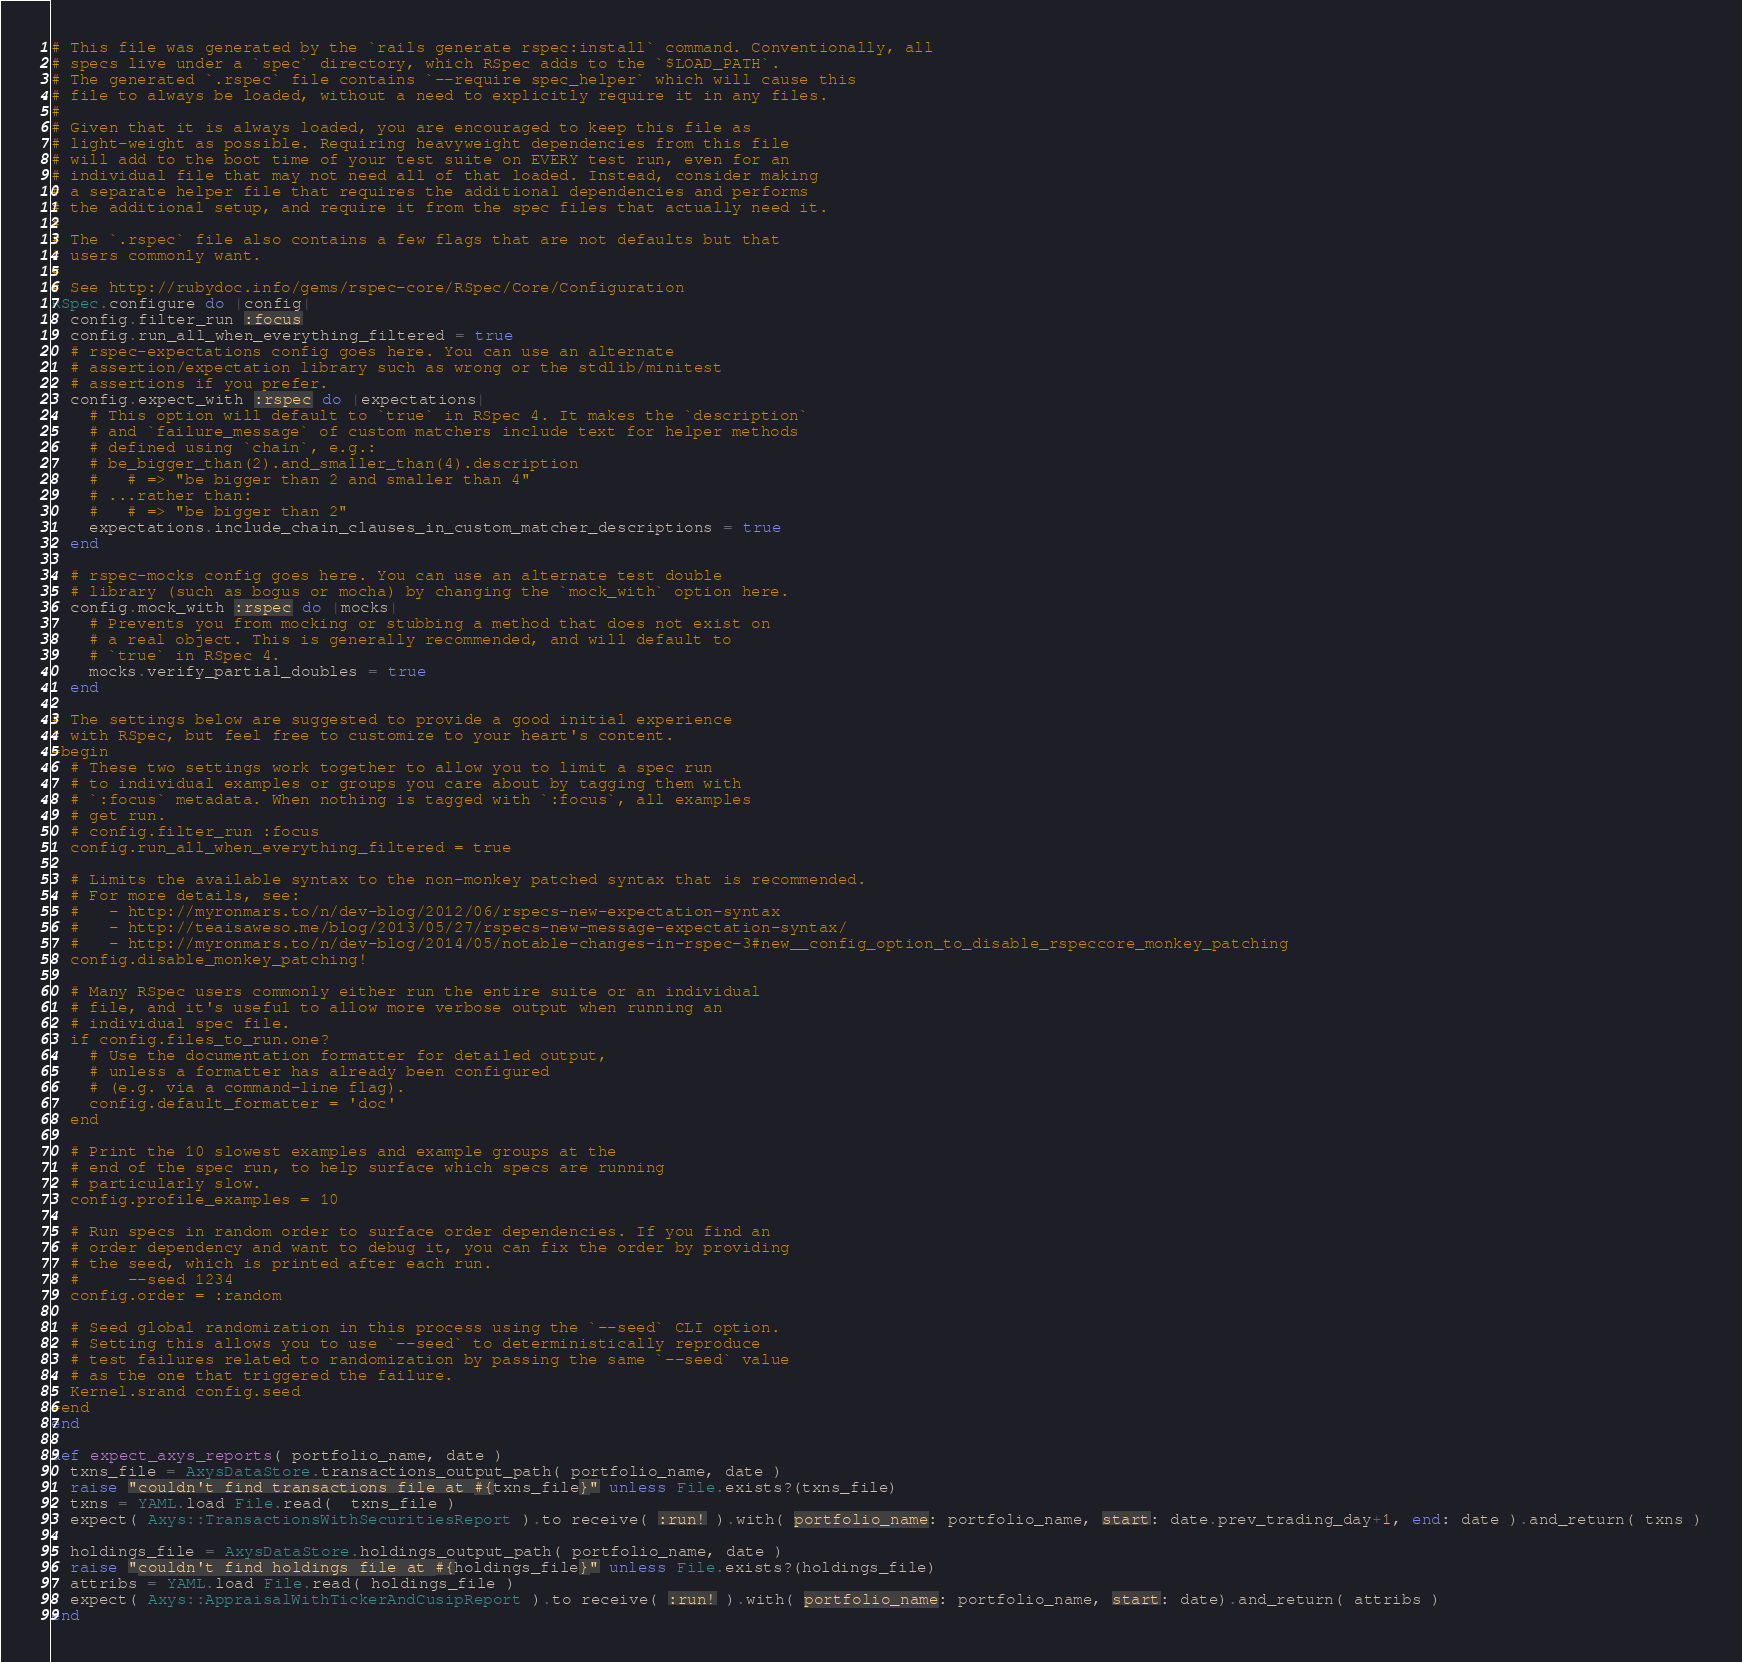<code> <loc_0><loc_0><loc_500><loc_500><_Ruby_># This file was generated by the `rails generate rspec:install` command. Conventionally, all
# specs live under a `spec` directory, which RSpec adds to the `$LOAD_PATH`.
# The generated `.rspec` file contains `--require spec_helper` which will cause this
# file to always be loaded, without a need to explicitly require it in any files.
#
# Given that it is always loaded, you are encouraged to keep this file as
# light-weight as possible. Requiring heavyweight dependencies from this file
# will add to the boot time of your test suite on EVERY test run, even for an
# individual file that may not need all of that loaded. Instead, consider making
# a separate helper file that requires the additional dependencies and performs
# the additional setup, and require it from the spec files that actually need it.
#
# The `.rspec` file also contains a few flags that are not defaults but that
# users commonly want.
#
# See http://rubydoc.info/gems/rspec-core/RSpec/Core/Configuration
RSpec.configure do |config|
  config.filter_run :focus
  config.run_all_when_everything_filtered = true
  # rspec-expectations config goes here. You can use an alternate
  # assertion/expectation library such as wrong or the stdlib/minitest
  # assertions if you prefer.
  config.expect_with :rspec do |expectations|
    # This option will default to `true` in RSpec 4. It makes the `description`
    # and `failure_message` of custom matchers include text for helper methods
    # defined using `chain`, e.g.:
    # be_bigger_than(2).and_smaller_than(4).description
    #   # => "be bigger than 2 and smaller than 4"
    # ...rather than:
    #   # => "be bigger than 2"
    expectations.include_chain_clauses_in_custom_matcher_descriptions = true
  end

  # rspec-mocks config goes here. You can use an alternate test double
  # library (such as bogus or mocha) by changing the `mock_with` option here.
  config.mock_with :rspec do |mocks|
    # Prevents you from mocking or stubbing a method that does not exist on
    # a real object. This is generally recommended, and will default to
    # `true` in RSpec 4.
    mocks.verify_partial_doubles = true
  end

# The settings below are suggested to provide a good initial experience
# with RSpec, but feel free to customize to your heart's content.
=begin
  # These two settings work together to allow you to limit a spec run
  # to individual examples or groups you care about by tagging them with
  # `:focus` metadata. When nothing is tagged with `:focus`, all examples
  # get run.
  # config.filter_run :focus
  config.run_all_when_everything_filtered = true

  # Limits the available syntax to the non-monkey patched syntax that is recommended.
  # For more details, see:
  #   - http://myronmars.to/n/dev-blog/2012/06/rspecs-new-expectation-syntax
  #   - http://teaisaweso.me/blog/2013/05/27/rspecs-new-message-expectation-syntax/
  #   - http://myronmars.to/n/dev-blog/2014/05/notable-changes-in-rspec-3#new__config_option_to_disable_rspeccore_monkey_patching
  config.disable_monkey_patching!

  # Many RSpec users commonly either run the entire suite or an individual
  # file, and it's useful to allow more verbose output when running an
  # individual spec file.
  if config.files_to_run.one?
    # Use the documentation formatter for detailed output,
    # unless a formatter has already been configured
    # (e.g. via a command-line flag).
    config.default_formatter = 'doc'
  end

  # Print the 10 slowest examples and example groups at the
  # end of the spec run, to help surface which specs are running
  # particularly slow.
  config.profile_examples = 10

  # Run specs in random order to surface order dependencies. If you find an
  # order dependency and want to debug it, you can fix the order by providing
  # the seed, which is printed after each run.
  #     --seed 1234
  config.order = :random

  # Seed global randomization in this process using the `--seed` CLI option.
  # Setting this allows you to use `--seed` to deterministically reproduce
  # test failures related to randomization by passing the same `--seed` value
  # as the one that triggered the failure.
  Kernel.srand config.seed
=end
end

def expect_axys_reports( portfolio_name, date )
  txns_file = AxysDataStore.transactions_output_path( portfolio_name, date )
  raise "couldn't find transactions file at #{txns_file}" unless File.exists?(txns_file)
  txns = YAML.load File.read(  txns_file )
  expect( Axys::TransactionsWithSecuritiesReport ).to receive( :run! ).with( portfolio_name: portfolio_name, start: date.prev_trading_day+1, end: date ).and_return( txns )

  holdings_file = AxysDataStore.holdings_output_path( portfolio_name, date )
  raise "couldn't find holdings file at #{holdings_file}" unless File.exists?(holdings_file)
  attribs = YAML.load File.read( holdings_file )
  expect( Axys::AppraisalWithTickerAndCusipReport ).to receive( :run! ).with( portfolio_name: portfolio_name, start: date).and_return( attribs )
end</code> 